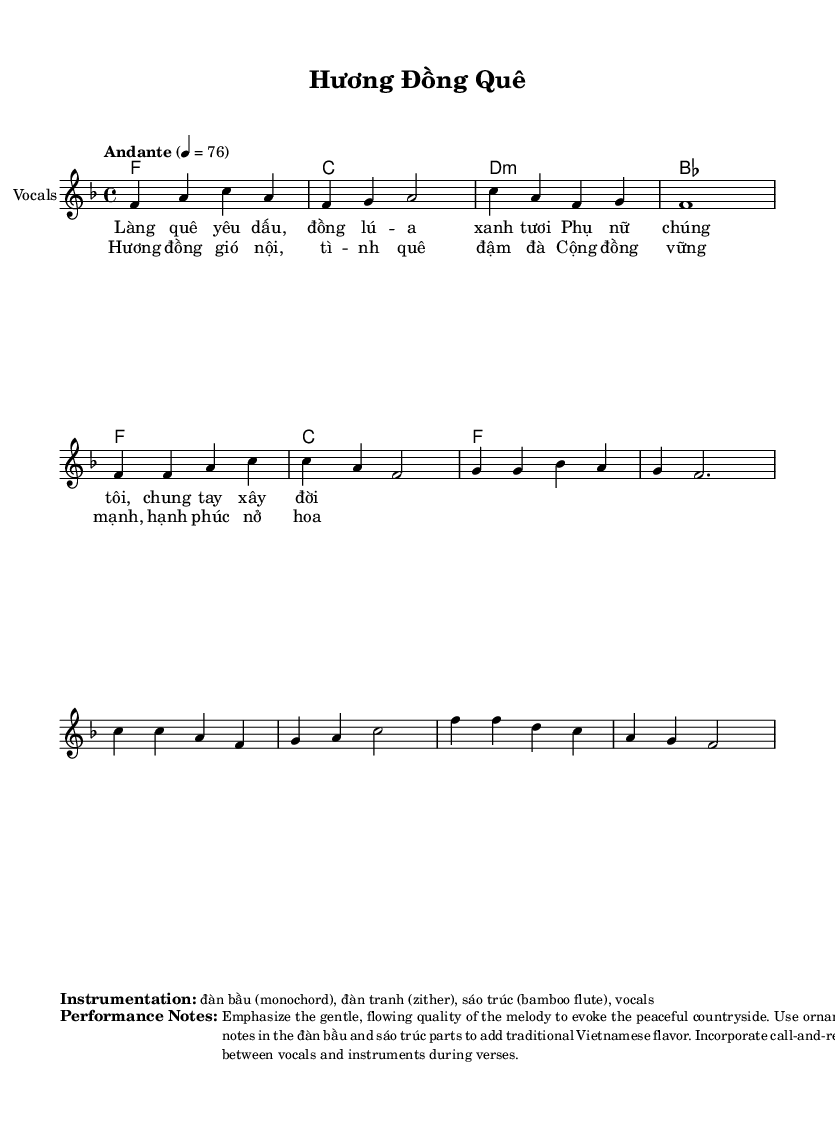What is the key signature of this music? The key signature is F major, which is indicated by one flat (Bb) on the staff.
Answer: F major What is the time signature of this music? The time signature is found at the beginning of the score, showing four beats per measure.
Answer: 4/4 What is the tempo marking of this piece? The tempo marking specifies "Andante," which denotes a moderately slow tempo, and it is set to 76 beats per minute.
Answer: Andante How many measures are in the chorus? By counting the musical notation in the chorus section, we can see that there are four measures present.
Answer: 4 What instruments are planned for this performance? The instrumentation is detailed in the markup, listing đàn bầu, đàn tranh, sáo trúc, and vocals.
Answer: đàn bầu, đàn tranh, sáo trúc, vocals What is the main theme of the melody? The main theme is established in the first few measures before the verse and the chorus, focusing on a flow reminiscent of peaceful countryside life.
Answer: Rural life How does the lyrics represent community empowerment? The lyrics express themes of collaboration and strength within the community, emphasizing women's unity and their role in building a better future.
Answer: Collaboration and strength 